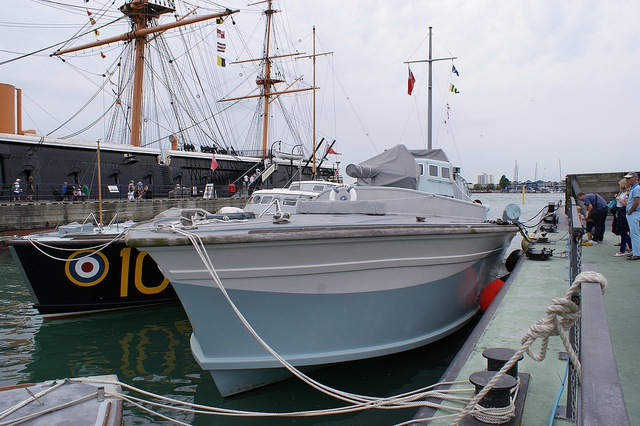Describe the objects in this image and their specific colors. I can see boat in lavender, gray, darkgray, and black tones, boat in lavender, black, darkgray, olive, and gray tones, people in lavender, black, gray, and darkgray tones, people in lavender, gray, maroon, and darkgray tones, and people in lavender, black, navy, and gray tones in this image. 